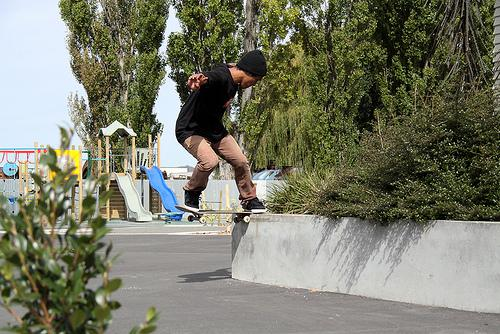Question: why is this boy in the air?
Choices:
A. He is happy.
B. He is doing karate.
C. He was jumping.
D. He is dunking.
Answer with the letter. Answer: C Question: what is the boy doing?
Choices:
A. He is running.
B. He is skateboarding.
C. He is swimming.
D. He is riding his bike.
Answer with the letter. Answer: B Question: what color is the boys shirt?
Choices:
A. Blue Plaid.
B. Green striped.
C. The shirt is black.
D. Solid orange.
Answer with the letter. Answer: C Question: how many slides do you see?
Choices:
A. Four.
B. One.
C. 2 slides.
D. Three.
Answer with the letter. Answer: C Question: where was the picture taken?
Choices:
A. Inside.
B. At school.
C. At work.
D. Outside.
Answer with the letter. Answer: D 